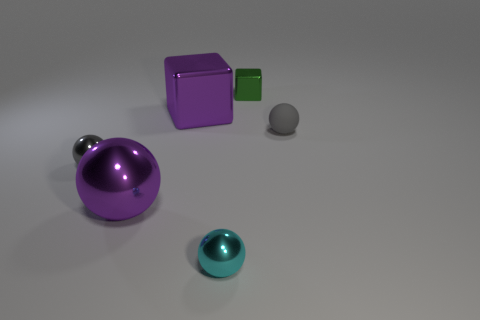What is the shape of the gray object on the right side of the small cyan metal object in front of the green shiny block?
Give a very brief answer. Sphere. Do the large block and the big metal sphere have the same color?
Offer a very short reply. Yes. How many blocks are either shiny objects or cyan things?
Your answer should be compact. 2. There is a sphere that is right of the gray metallic thing and to the left of the large purple metallic cube; what is its material?
Offer a terse response. Metal. What number of large spheres are on the left side of the purple sphere?
Ensure brevity in your answer.  0. Does the small gray thing on the left side of the small cyan metallic sphere have the same material as the big object in front of the tiny gray metallic sphere?
Provide a succinct answer. Yes. What number of objects are either large purple cubes that are behind the cyan sphere or large green cylinders?
Ensure brevity in your answer.  1. Are there fewer small rubber spheres behind the gray rubber ball than cyan things to the left of the green block?
Your answer should be compact. Yes. What number of other objects are the same size as the purple cube?
Offer a very short reply. 1. Is the purple ball made of the same material as the tiny gray ball that is to the left of the matte object?
Ensure brevity in your answer.  Yes. 